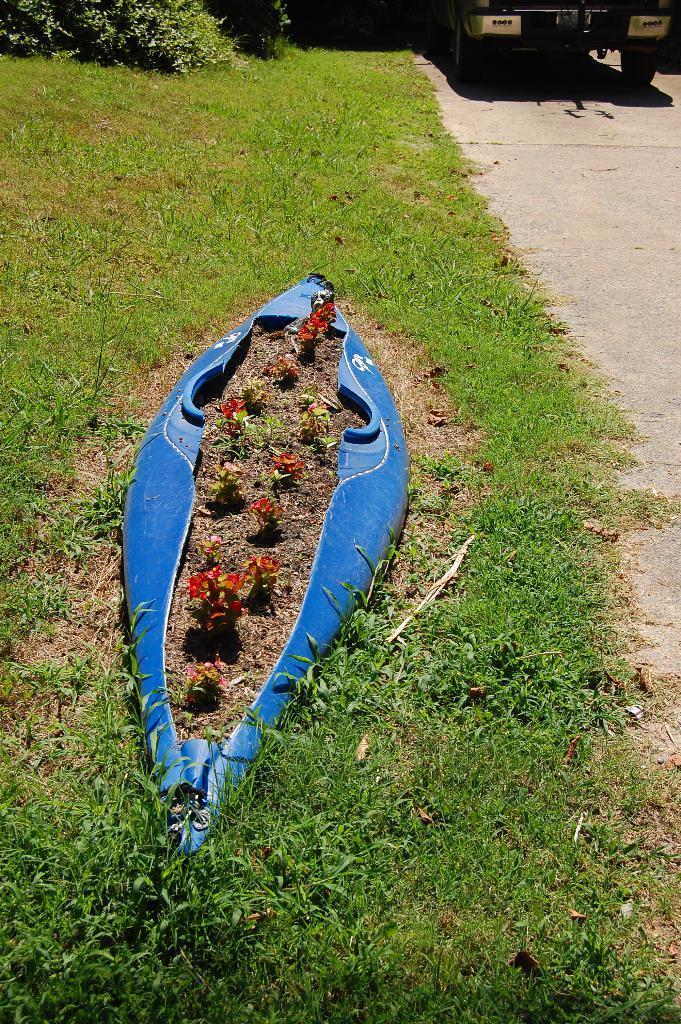Could you give a brief overview of what you see in this image? In the foreground of the picture there are plants, grass, road and a blue color object. At the top there are plants, vehicle, road and grass. 